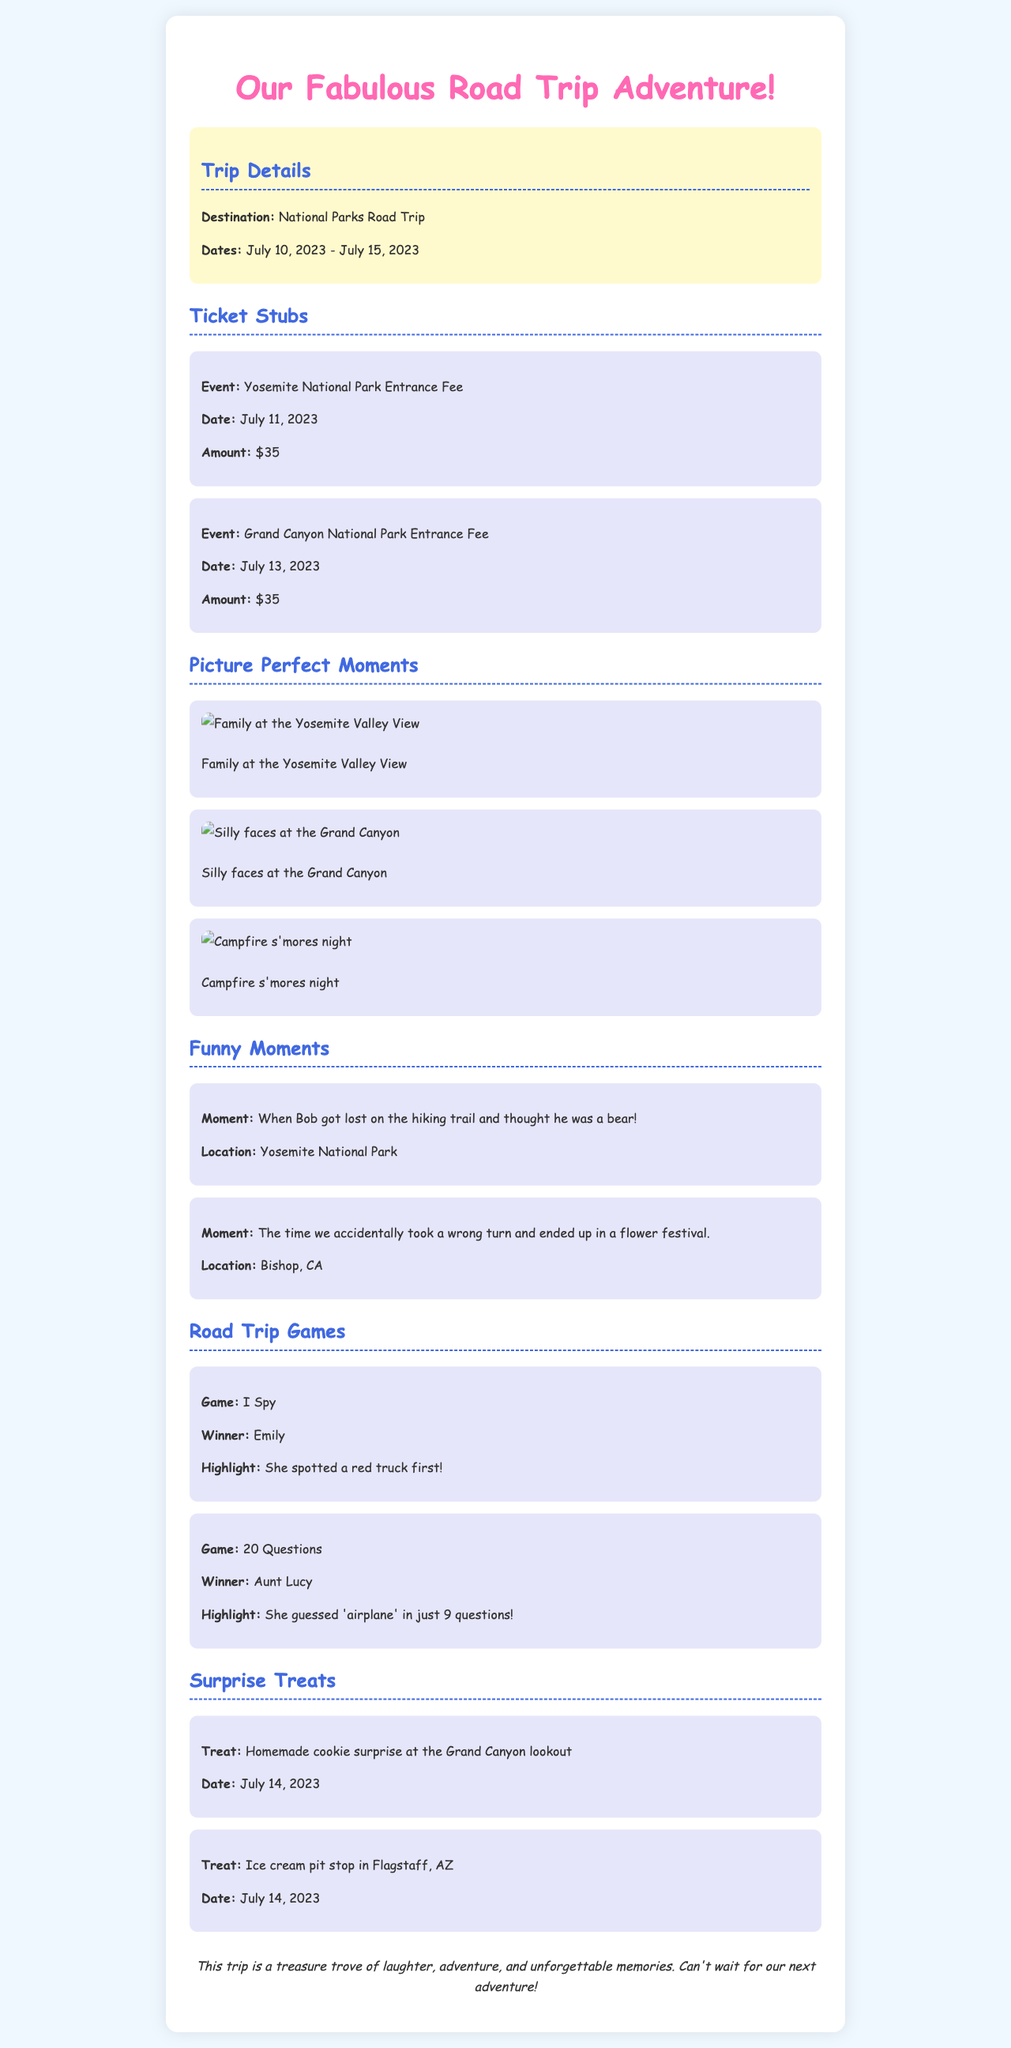What is the destination of the road trip? The document states the trip's destination in the 'Trip Details' section, which is National Parks Road Trip.
Answer: National Parks Road Trip What was the entry fee for Yosemite National Park? The 'Ticket Stubs' section lists the event along with its amount for Yosemite National Park, which is $35.
Answer: $35 Who won the game of I Spy? The document specifies the winner in the 'Road Trip Games' section stating that Emily won.
Answer: Emily What highlight is mentioned for the game 20 Questions? The highlight for the game of 20 Questions mentions that Aunt Lucy guessed 'airplane' in just 9 questions.
Answer: She guessed 'airplane' in just 9 questions What date was the homemade cookie surprise at Grand Canyon? The 'Surprise Treats' section provides the date, which is July 14, 2023.
Answer: July 14, 2023 What funny moment happened at Yosemite National Park? The document notes a specific moment involving Bob getting lost and thinking he was a bear in the 'Funny Moments' section.
Answer: Bob got lost on the hiking trail and thought he was a bear What event occurred on July 13, 2023? The 'Ticket Stubs' section outlines that the Grand Canyon National Park Entrance Fee was paid on this date.
Answer: Grand Canyon National Park Entrance Fee Which state did the ice cream pit stop occur in? The document states that the ice cream pit stop occurred in Flagstaff, AZ, located in Arizona.
Answer: Arizona 